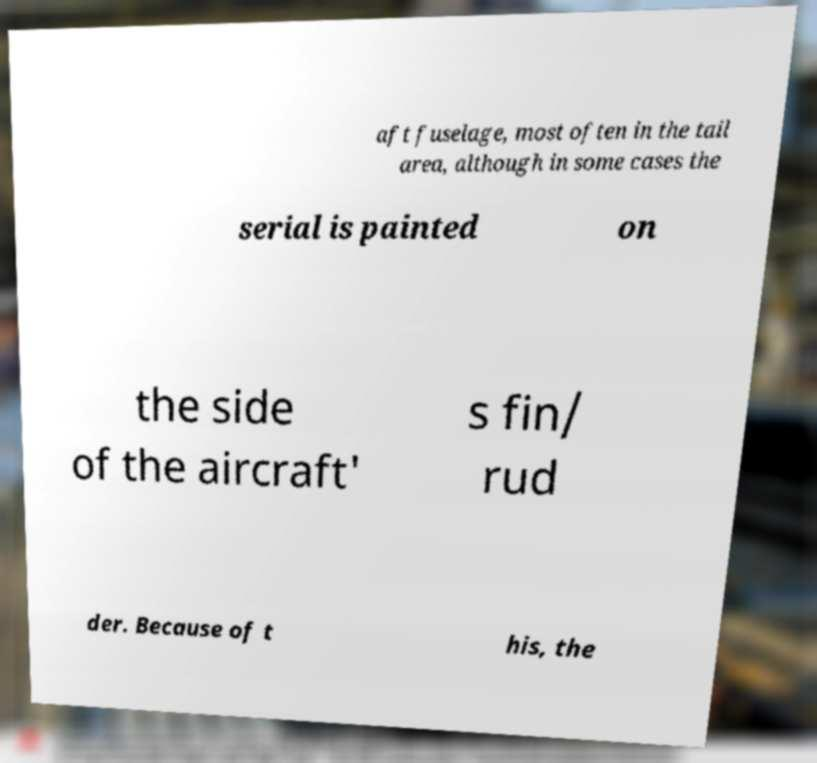Please identify and transcribe the text found in this image. aft fuselage, most often in the tail area, although in some cases the serial is painted on the side of the aircraft' s fin/ rud der. Because of t his, the 